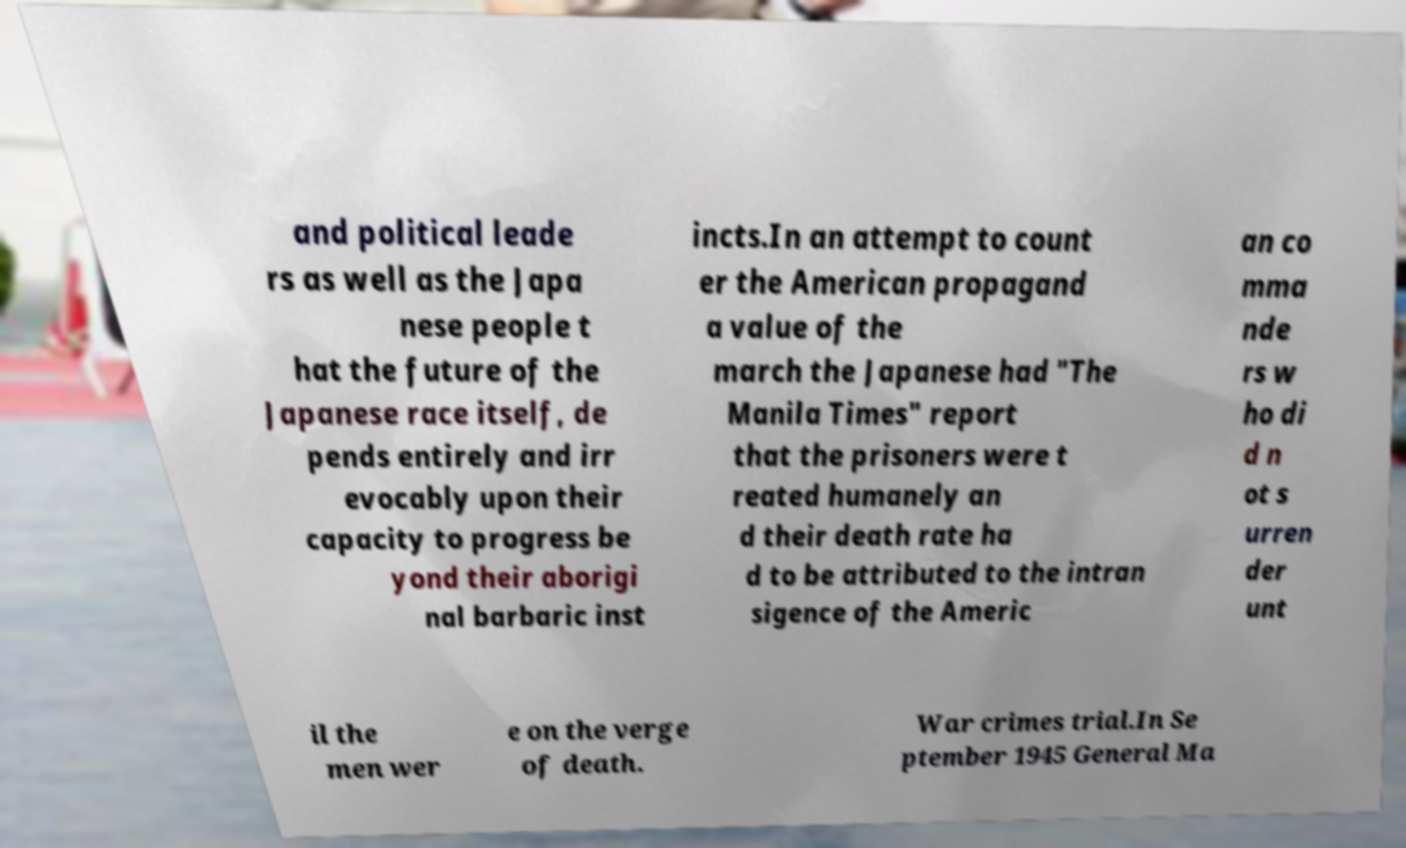Could you assist in decoding the text presented in this image and type it out clearly? and political leade rs as well as the Japa nese people t hat the future of the Japanese race itself, de pends entirely and irr evocably upon their capacity to progress be yond their aborigi nal barbaric inst incts.In an attempt to count er the American propagand a value of the march the Japanese had "The Manila Times" report that the prisoners were t reated humanely an d their death rate ha d to be attributed to the intran sigence of the Americ an co mma nde rs w ho di d n ot s urren der unt il the men wer e on the verge of death. War crimes trial.In Se ptember 1945 General Ma 